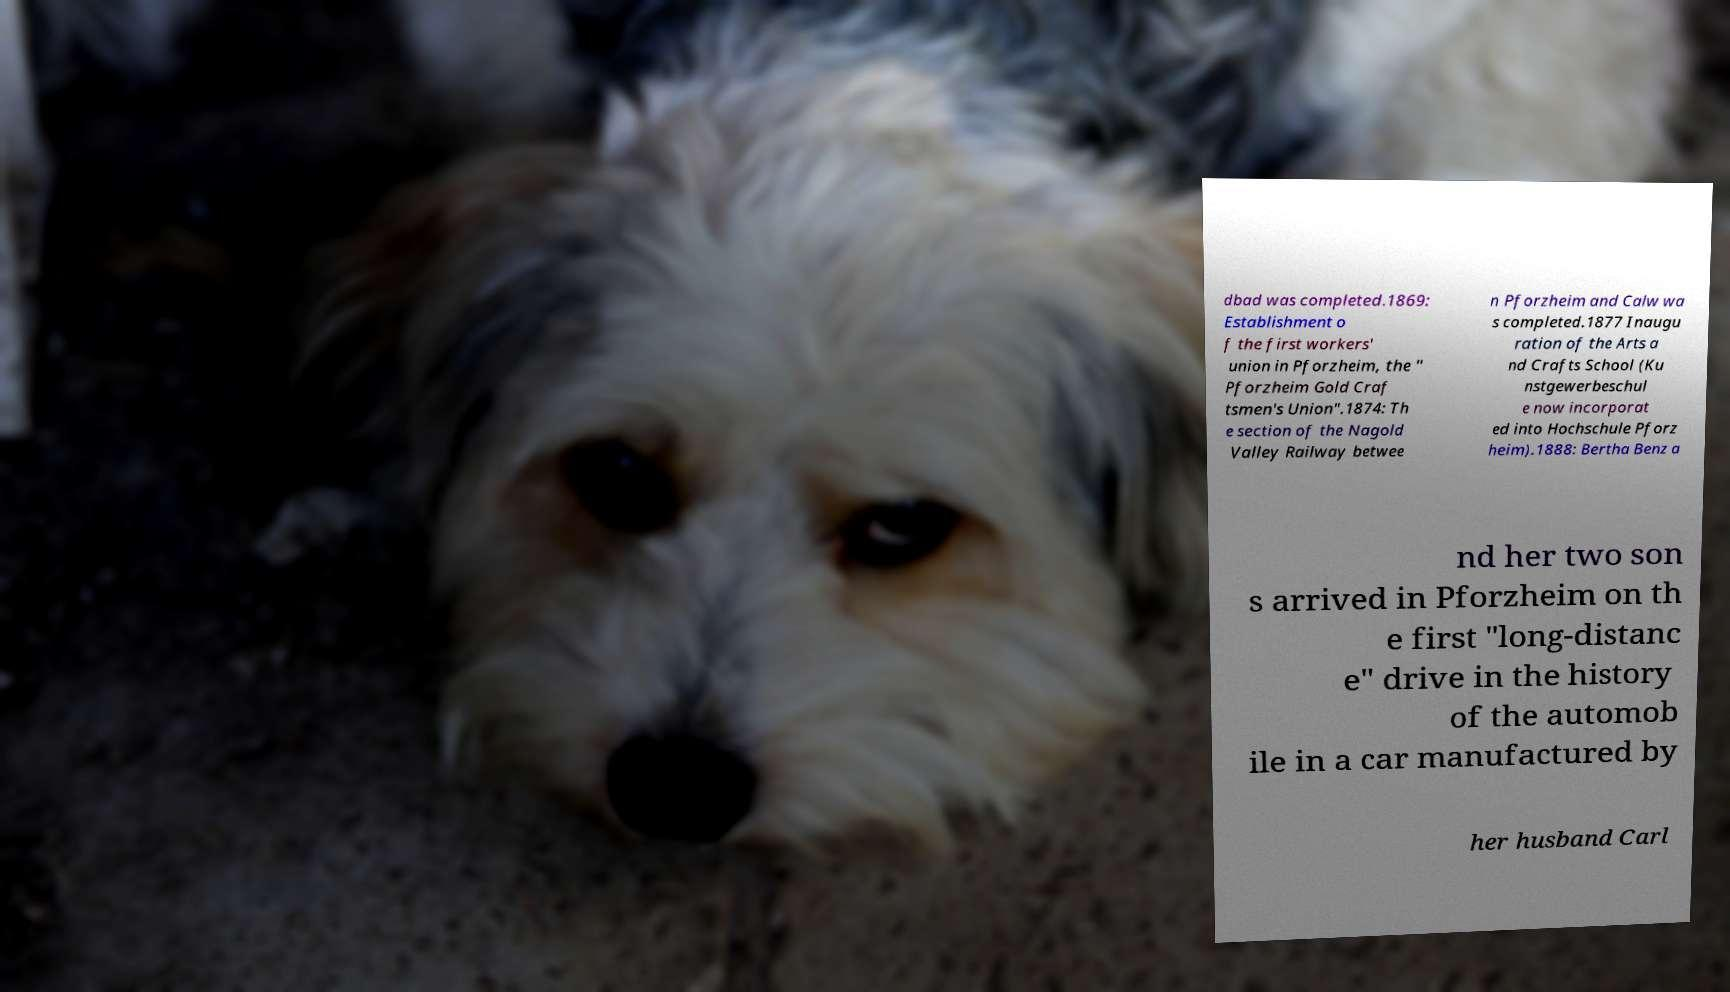Can you accurately transcribe the text from the provided image for me? dbad was completed.1869: Establishment o f the first workers' union in Pforzheim, the " Pforzheim Gold Craf tsmen's Union".1874: Th e section of the Nagold Valley Railway betwee n Pforzheim and Calw wa s completed.1877 Inaugu ration of the Arts a nd Crafts School (Ku nstgewerbeschul e now incorporat ed into Hochschule Pforz heim).1888: Bertha Benz a nd her two son s arrived in Pforzheim on th e first "long-distanc e" drive in the history of the automob ile in a car manufactured by her husband Carl 